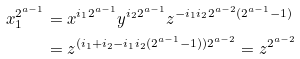Convert formula to latex. <formula><loc_0><loc_0><loc_500><loc_500>x _ { 1 } ^ { 2 ^ { a - 1 } } & = x ^ { i _ { 1 } 2 ^ { a - 1 } } y ^ { i _ { 2 } 2 ^ { a - 1 } } z ^ { - i _ { 1 } i _ { 2 } 2 ^ { a - 2 } ( 2 ^ { a - 1 } - 1 ) } \\ & = z ^ { ( i _ { 1 } + i _ { 2 } - i _ { 1 } i _ { 2 } ( 2 ^ { a - 1 } - 1 ) ) 2 ^ { a - 2 } } = z ^ { 2 ^ { a - 2 } }</formula> 